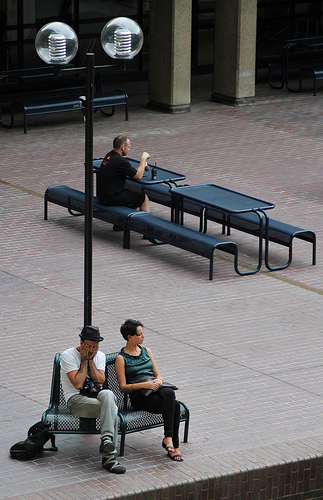What activities might the people on the bench be engaged in, and what does this suggest about the time of day or setting? The man appears to be deeply focused on reading, likely enjoying a quiet moment, while the woman seems to be resting or waiting. The lighting and shadows suggest it's either early morning or late afternoon, a typical time for people to enjoy a bit of calm in public spaces. 